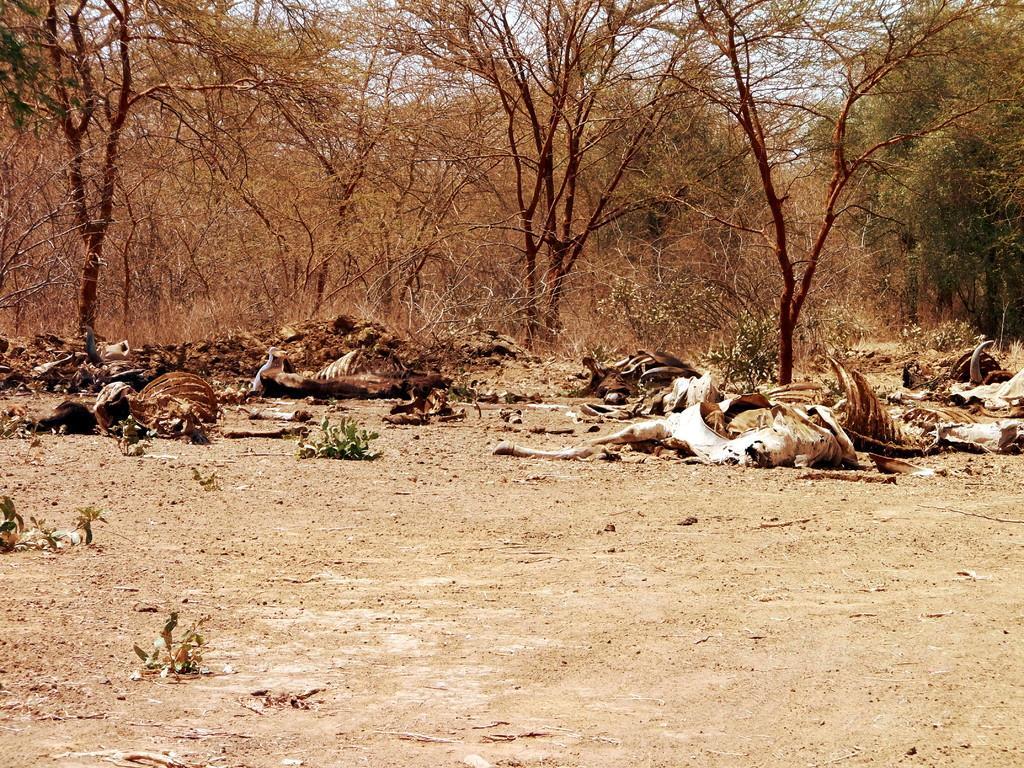In one or two sentences, can you explain what this image depicts? In this image, this looks like the animals flesh lying on the ground. These are the trees and plants. 